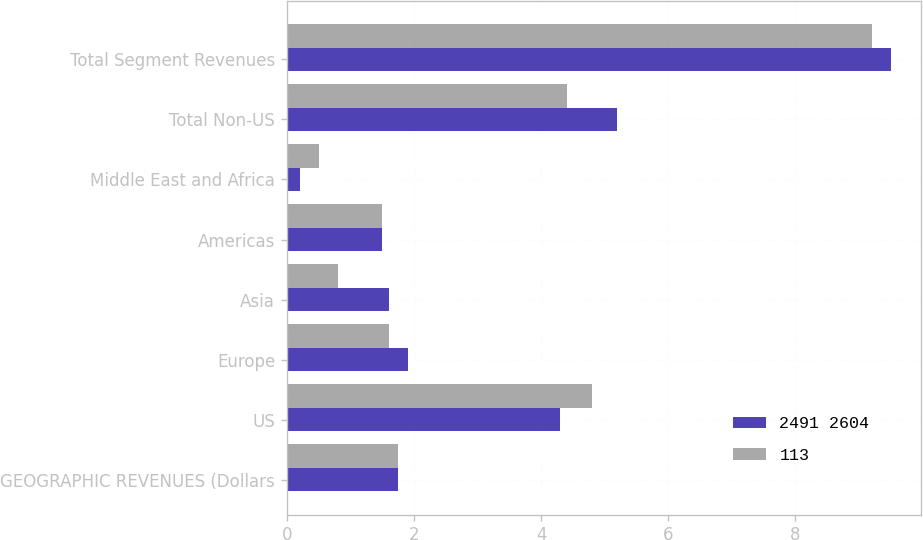<chart> <loc_0><loc_0><loc_500><loc_500><stacked_bar_chart><ecel><fcel>GEOGRAPHIC REVENUES (Dollars<fcel>US<fcel>Europe<fcel>Asia<fcel>Americas<fcel>Middle East and Africa<fcel>Total Non-US<fcel>Total Segment Revenues<nl><fcel>2491 2604<fcel>1.75<fcel>4.3<fcel>1.9<fcel>1.6<fcel>1.5<fcel>0.2<fcel>5.2<fcel>9.5<nl><fcel>113<fcel>1.75<fcel>4.8<fcel>1.6<fcel>0.8<fcel>1.5<fcel>0.5<fcel>4.4<fcel>9.2<nl></chart> 